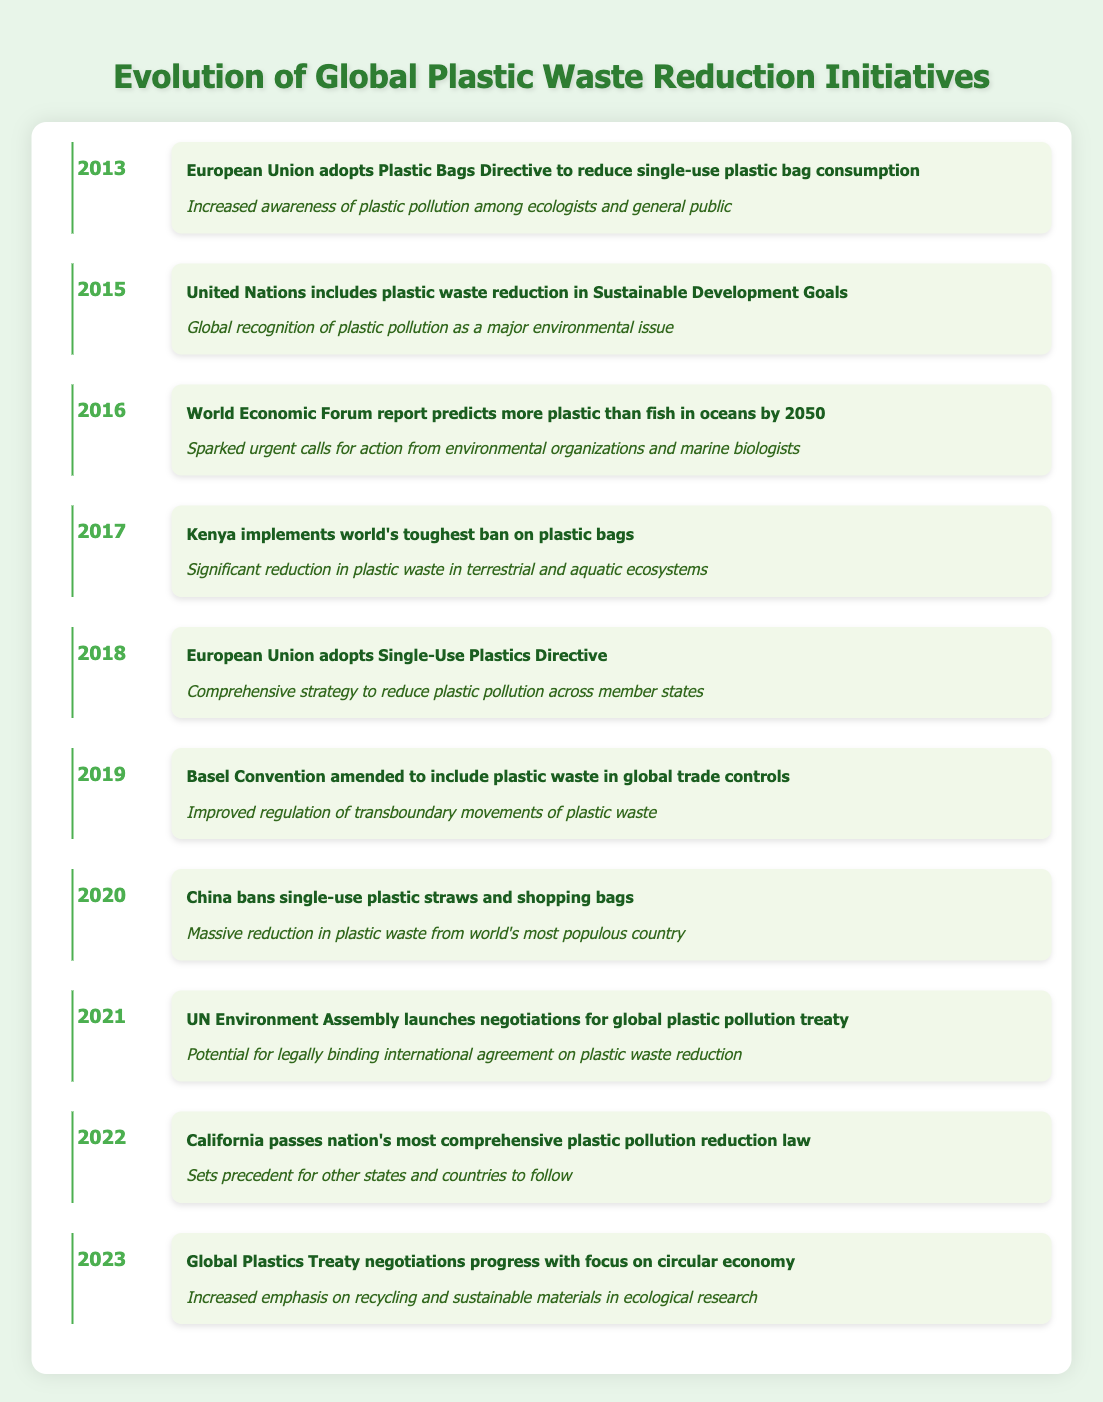What event happened in 2015? The table lists the event for 2015 as the "United Nations includes plastic waste reduction in Sustainable Development Goals." This fact can be directly retrieved from the 2015 row in the timeline.
Answer: United Nations includes plastic waste reduction in Sustainable Development Goals How many years between the introduction of the Plastic Bags Directive and the Single-Use Plastics Directive? The Plastic Bags Directive was adopted in 2013 and the Single-Use Plastics Directive in 2018. By subtracting these years (2018 - 2013), we find it was 5 years between the two events.
Answer: 5 years Was Kenya's plastic bag ban implemented before or after the World Economic Forum report? Kenya's ban took place in 2017 while the World Economic Forum report was published in 2016. Since 2017 comes after 2016, the ban was implemented after the report.
Answer: After Which year saw the first significant international recognition of plastic pollution? The first significant international recognition of plastic pollution listed in the table is in 2015 when the United Nations included plastic waste reduction in Sustainable Development Goals. This marked a critical point in global awareness.
Answer: 2015 How many of the listed events took place after 2018? The events that took place after 2018 are in 2019, 2020, 2021, 2022, and 2023, which sums up to 5 events in total. To find the count, I looked at the years listed after 2018 and noted them.
Answer: 5 events What was the impact of China's ban on single-use plastic straws and shopping bags in 2020? The impact of China's ban in 2020, according to the timeline, was a massive reduction in plastic waste from the world's most populous country. This reflects the significance of such an initiative given China's population size.
Answer: Massive reduction in plastic waste How does the 2022 California law relate to other states or countries? The 2022 law passed in California is described as setting a precedent for other states and countries to follow. This suggests that California's initiative is seen as a model for similar legislation elsewhere.
Answer: Sets precedent for others Is there an event in which an international treaty was pursued to address plastic waste? Yes, in 2021, the UN Environment Assembly launched negotiations for a global plastic pollution treaty, signaling international efforts to tackle the issue of plastic waste. This is confirmed in the timeline's entries.
Answer: Yes, in 2021 What prediction did the World Economic Forum make regarding plastic in oceans? The World Economic Forum report from 2016 predicted that there would be more plastic than fish in oceans by 2050. This alarming forecast is intended to draw attention to the urgency of addressing plastic pollution.
Answer: More plastic than fish by 2050 